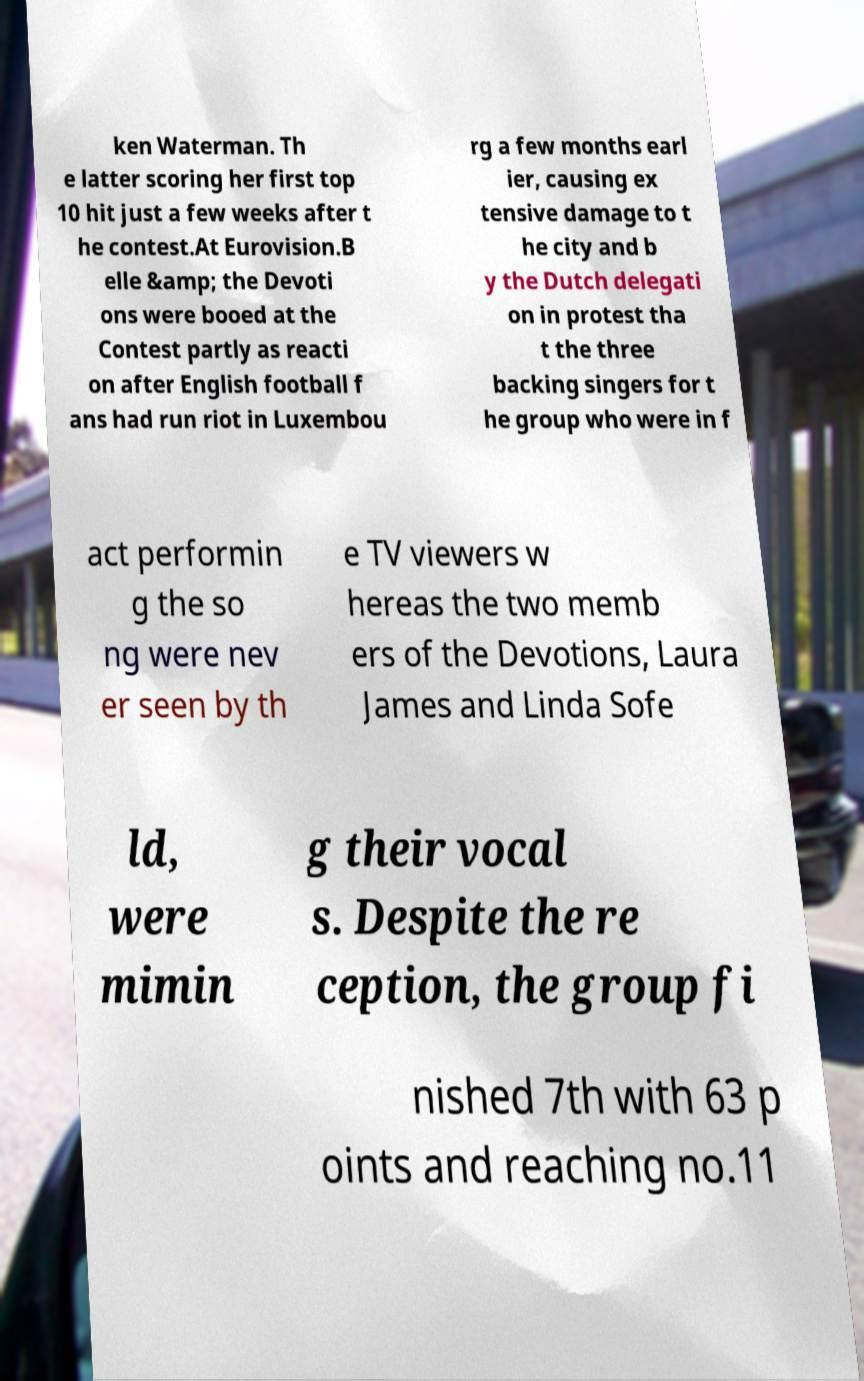Please read and relay the text visible in this image. What does it say? ken Waterman. Th e latter scoring her first top 10 hit just a few weeks after t he contest.At Eurovision.B elle &amp; the Devoti ons were booed at the Contest partly as reacti on after English football f ans had run riot in Luxembou rg a few months earl ier, causing ex tensive damage to t he city and b y the Dutch delegati on in protest tha t the three backing singers for t he group who were in f act performin g the so ng were nev er seen by th e TV viewers w hereas the two memb ers of the Devotions, Laura James and Linda Sofe ld, were mimin g their vocal s. Despite the re ception, the group fi nished 7th with 63 p oints and reaching no.11 